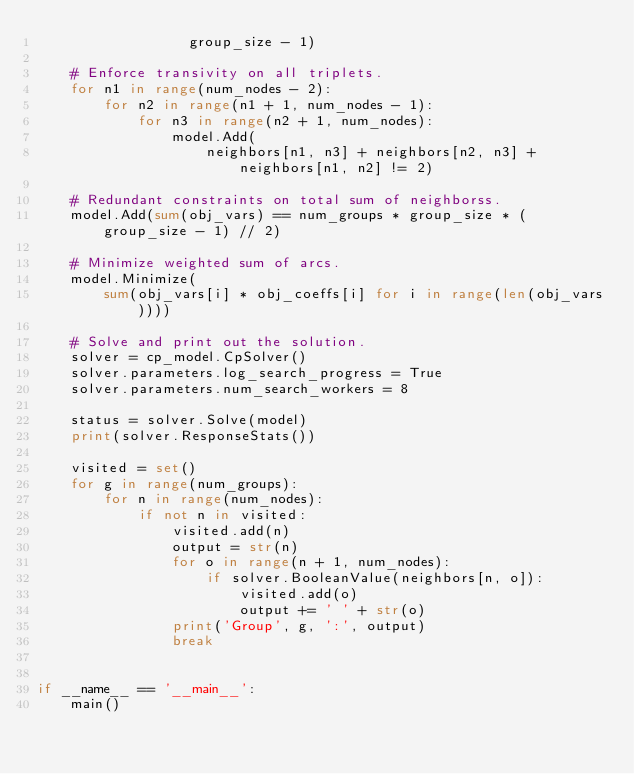Convert code to text. <code><loc_0><loc_0><loc_500><loc_500><_Python_>                  group_size - 1)
    
    # Enforce transivity on all triplets.
    for n1 in range(num_nodes - 2):
        for n2 in range(n1 + 1, num_nodes - 1):
            for n3 in range(n2 + 1, num_nodes):
                model.Add(
                    neighbors[n1, n3] + neighbors[n2, n3] + neighbors[n1, n2] != 2)

    # Redundant constraints on total sum of neighborss.
    model.Add(sum(obj_vars) == num_groups * group_size * (group_size - 1) // 2)

    # Minimize weighted sum of arcs.
    model.Minimize(
        sum(obj_vars[i] * obj_coeffs[i] for i in range(len(obj_vars))))

    # Solve and print out the solution.
    solver = cp_model.CpSolver()
    solver.parameters.log_search_progress = True
    solver.parameters.num_search_workers = 8

    status = solver.Solve(model)
    print(solver.ResponseStats())

    visited = set()
    for g in range(num_groups):
        for n in range(num_nodes):
            if not n in visited:
                visited.add(n)
                output = str(n)
                for o in range(n + 1, num_nodes):
                    if solver.BooleanValue(neighbors[n, o]):
                        visited.add(o)
                        output += ' ' + str(o)
                print('Group', g, ':', output)
                break


if __name__ == '__main__':
    main()
</code> 